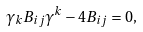Convert formula to latex. <formula><loc_0><loc_0><loc_500><loc_500>\gamma _ { k } B _ { i j } \gamma ^ { k } - 4 B _ { i j } = 0 ,</formula> 